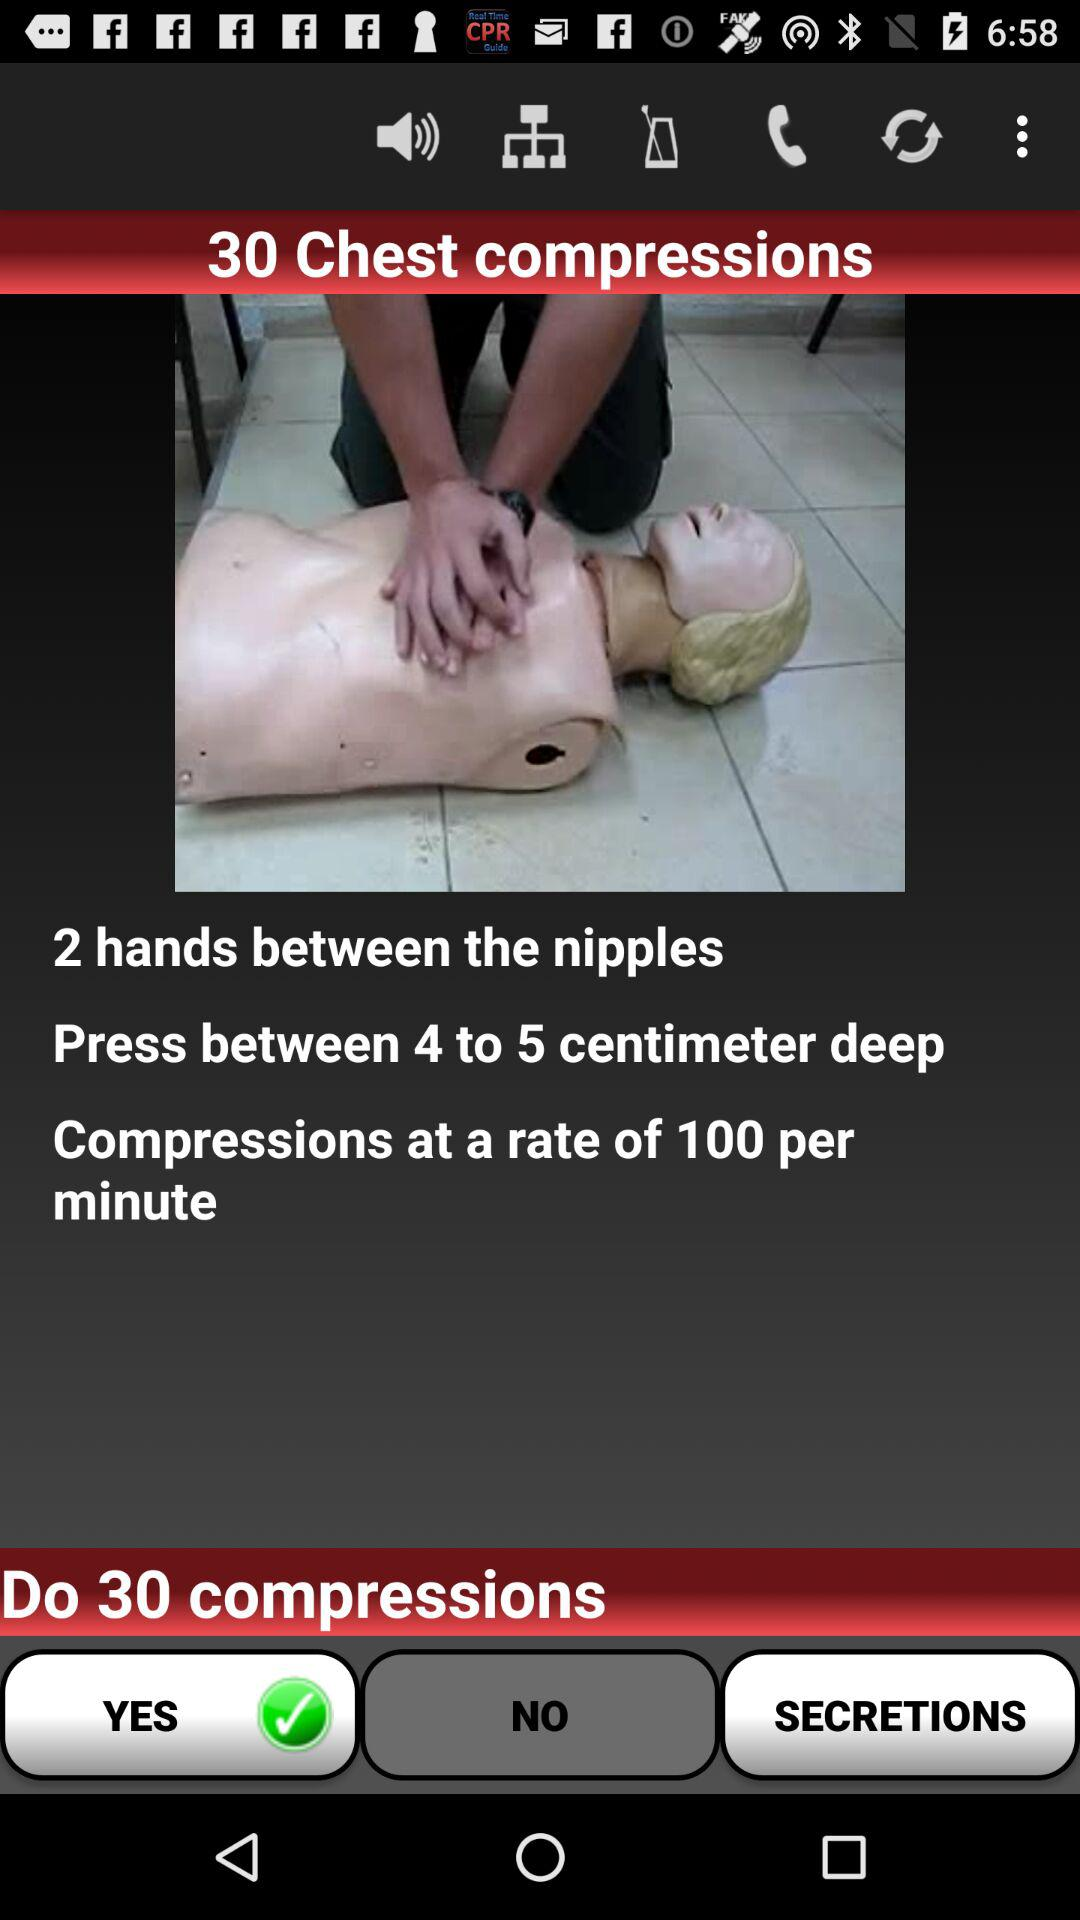What should be the compression rate? The compression rate should be 100 per minute. 